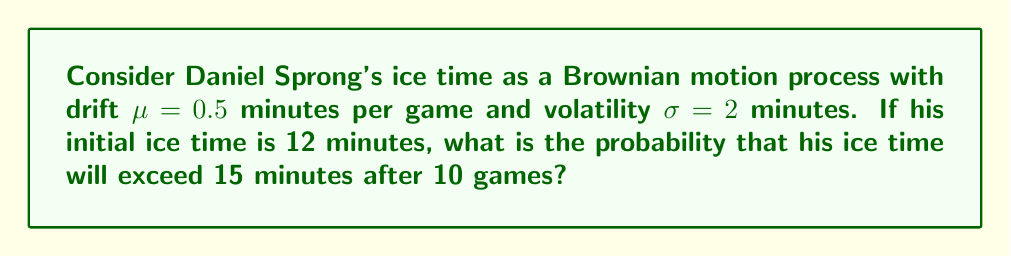What is the answer to this math problem? To solve this problem, we'll use the properties of Brownian motion:

1) Let $X_t$ represent Sprong's ice time at game t. We know that $X_0 = 12$ minutes.

2) For Brownian motion with drift, we have:
   $X_t \sim N(X_0 + \mu t, \sigma^2 t)$

3) After 10 games (t = 10), the distribution of ice time will be:
   $X_{10} \sim N(12 + 0.5 * 10, 2^2 * 10)$
   $X_{10} \sim N(17, 40)$

4) We want to find $P(X_{10} > 15)$. To standardize this:
   $P(X_{10} > 15) = P(\frac{X_{10} - 17}{\sqrt{40}} > \frac{15 - 17}{\sqrt{40}})$
   $= P(Z > \frac{-2}{\sqrt{40}}) = P(Z > -0.3162)$

5) Using the standard normal distribution table or calculator:
   $P(Z > -0.3162) = 1 - P(Z < -0.3162) = 1 - 0.3759 = 0.6241$

Therefore, the probability that Sprong's ice time will exceed 15 minutes after 10 games is approximately 0.6241 or 62.41%.
Answer: 0.6241 